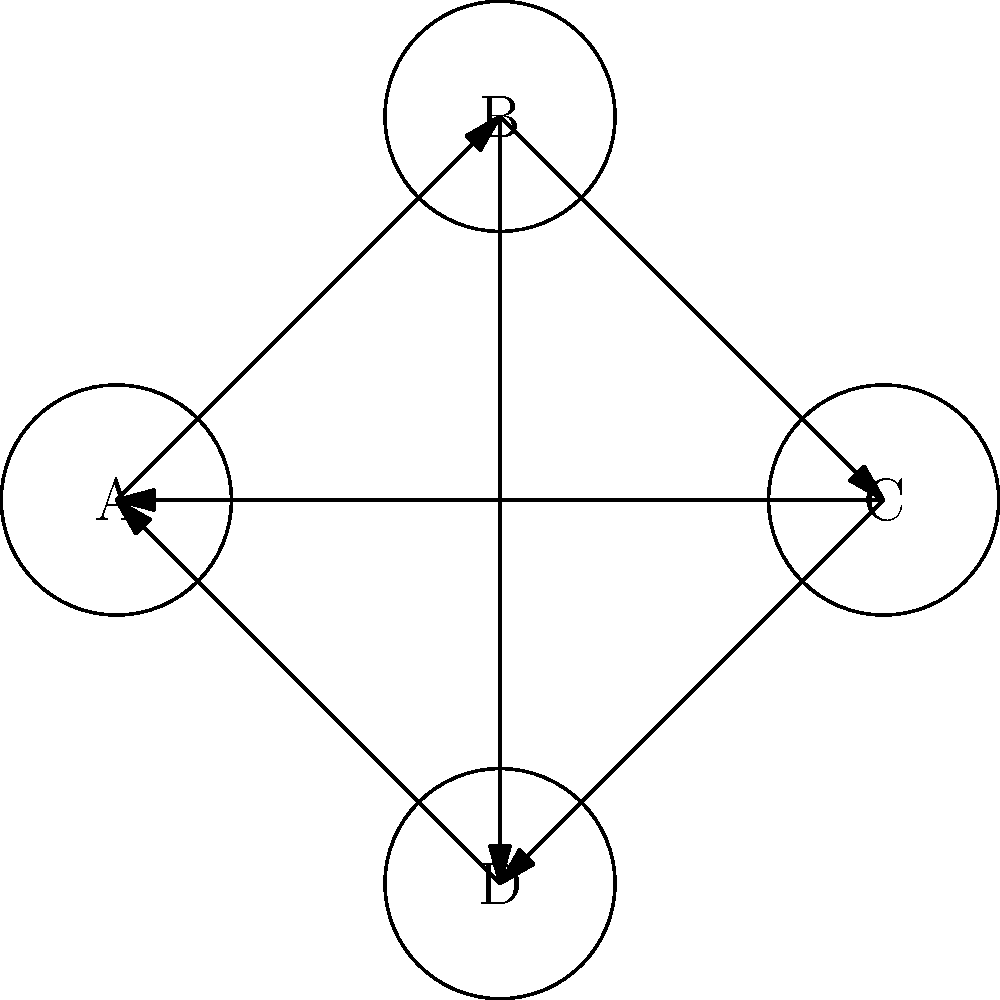In the given directed graph, identify all the cycles present. How many cycles are there in total? Let's approach this step-by-step:

1. First, we need to understand what a cycle is in a directed graph. A cycle is a path that starts and ends at the same vertex, following the direction of the edges.

2. Now, let's identify all the cycles in this graph:

   a) A → B → C → A
   b) A → B → D → A
   c) A → B → C → D → A

3. To ensure we haven't missed any cycles, let's check from each vertex:

   From A: We've covered all cycles starting from A.
   From B: Any cycle from B must return to B, which is not possible in this graph.
   From C: C → A → B → C is a cycle, but it's the same as cycle (a) starting from A.
   From D: D → A → B → D is a cycle, but it's the same as cycle (b) starting from A.

4. Therefore, we have identified all unique cycles in the graph.

5. Counting the cycles we found: There are 3 distinct cycles in total.
Answer: 3 cycles 